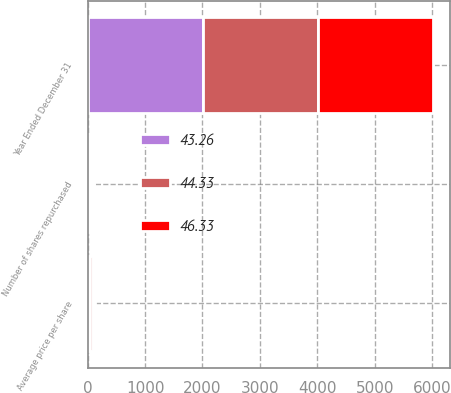Convert chart. <chart><loc_0><loc_0><loc_500><loc_500><stacked_bar_chart><ecel><fcel>Year Ended December 31<fcel>Number of shares repurchased<fcel>Average price per share<nl><fcel>44.33<fcel>2005<fcel>46<fcel>43.26<nl><fcel>46.33<fcel>2004<fcel>38<fcel>46.33<nl><fcel>43.26<fcel>2003<fcel>33<fcel>44.33<nl></chart> 